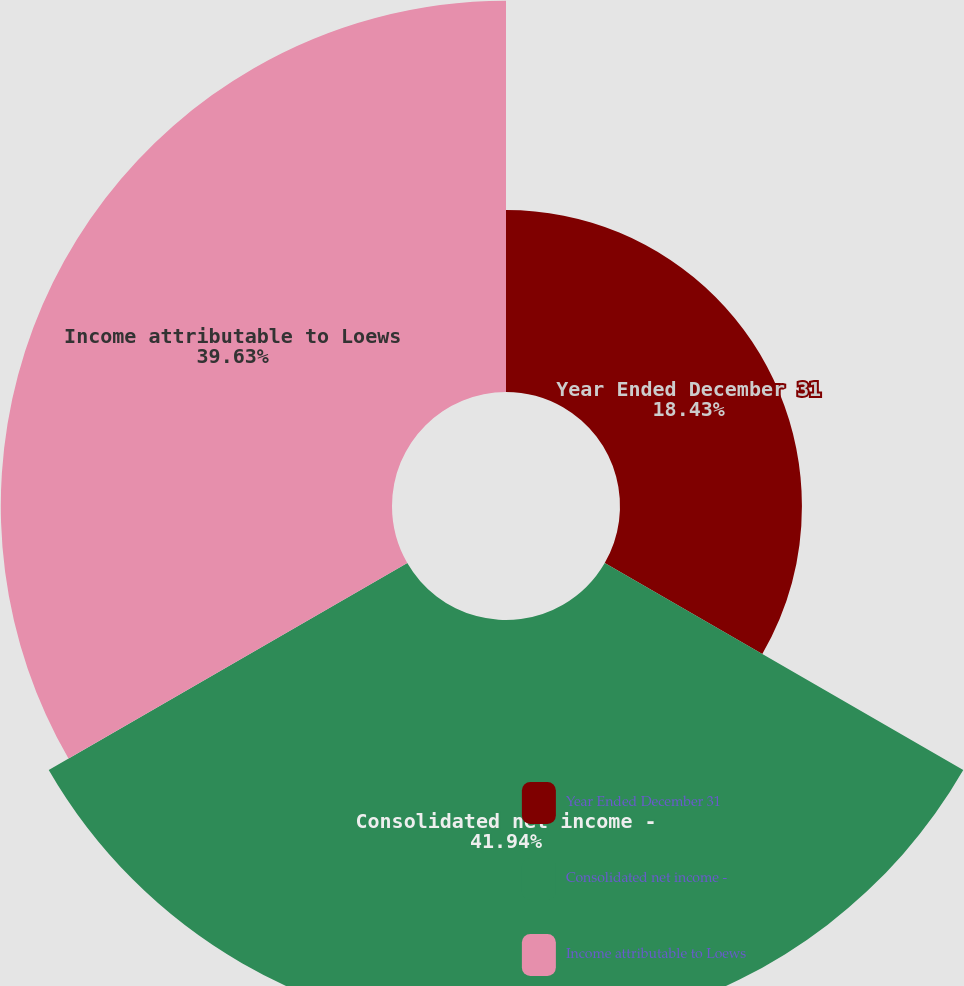Convert chart to OTSL. <chart><loc_0><loc_0><loc_500><loc_500><pie_chart><fcel>Year Ended December 31<fcel>Consolidated net income -<fcel>Income attributable to Loews<nl><fcel>18.43%<fcel>41.94%<fcel>39.63%<nl></chart> 